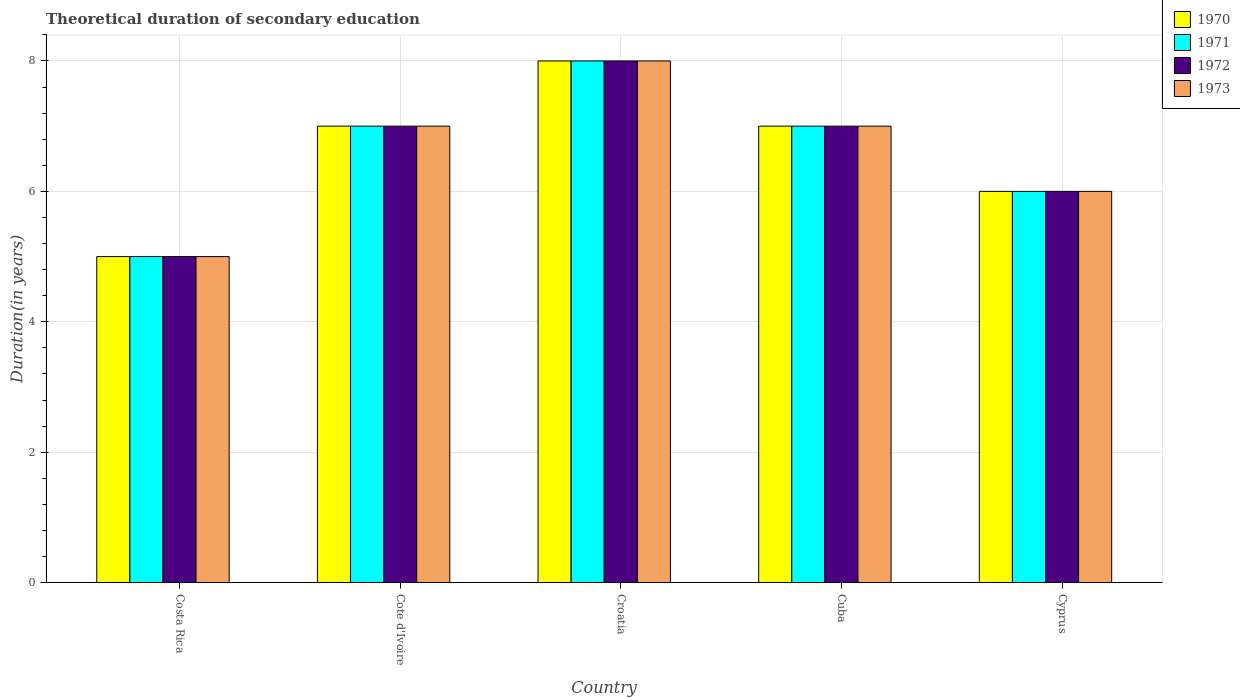How many different coloured bars are there?
Your answer should be very brief. 4. Are the number of bars per tick equal to the number of legend labels?
Keep it short and to the point. Yes. Are the number of bars on each tick of the X-axis equal?
Keep it short and to the point. Yes. How many bars are there on the 4th tick from the left?
Keep it short and to the point. 4. What is the label of the 2nd group of bars from the left?
Keep it short and to the point. Cote d'Ivoire. What is the total theoretical duration of secondary education in 1973 in Cote d'Ivoire?
Ensure brevity in your answer.  7. Across all countries, what is the maximum total theoretical duration of secondary education in 1973?
Ensure brevity in your answer.  8. In which country was the total theoretical duration of secondary education in 1973 maximum?
Your answer should be compact. Croatia. In which country was the total theoretical duration of secondary education in 1970 minimum?
Your response must be concise. Costa Rica. What is the total total theoretical duration of secondary education in 1971 in the graph?
Give a very brief answer. 33. What is the average total theoretical duration of secondary education in 1973 per country?
Offer a very short reply. 6.6. What is the difference between the total theoretical duration of secondary education of/in 1973 and total theoretical duration of secondary education of/in 1970 in Croatia?
Your response must be concise. 0. In how many countries, is the total theoretical duration of secondary education in 1971 greater than 5.6 years?
Give a very brief answer. 4. What is the ratio of the total theoretical duration of secondary education in 1971 in Cuba to that in Cyprus?
Provide a succinct answer. 1.17. Is the total theoretical duration of secondary education in 1971 in Costa Rica less than that in Cuba?
Your response must be concise. Yes. What is the difference between the highest and the lowest total theoretical duration of secondary education in 1972?
Offer a terse response. 3. Is it the case that in every country, the sum of the total theoretical duration of secondary education in 1970 and total theoretical duration of secondary education in 1971 is greater than the sum of total theoretical duration of secondary education in 1973 and total theoretical duration of secondary education in 1972?
Ensure brevity in your answer.  No. What does the 1st bar from the left in Cote d'Ivoire represents?
Give a very brief answer. 1970. Is it the case that in every country, the sum of the total theoretical duration of secondary education in 1973 and total theoretical duration of secondary education in 1972 is greater than the total theoretical duration of secondary education in 1971?
Provide a short and direct response. Yes. How many bars are there?
Provide a succinct answer. 20. What is the difference between two consecutive major ticks on the Y-axis?
Ensure brevity in your answer.  2. Are the values on the major ticks of Y-axis written in scientific E-notation?
Make the answer very short. No. Does the graph contain any zero values?
Offer a terse response. No. What is the title of the graph?
Your response must be concise. Theoretical duration of secondary education. What is the label or title of the X-axis?
Offer a very short reply. Country. What is the label or title of the Y-axis?
Keep it short and to the point. Duration(in years). What is the Duration(in years) in 1971 in Costa Rica?
Your response must be concise. 5. What is the Duration(in years) in 1973 in Costa Rica?
Offer a terse response. 5. What is the Duration(in years) in 1972 in Cote d'Ivoire?
Keep it short and to the point. 7. What is the Duration(in years) in 1973 in Cote d'Ivoire?
Offer a terse response. 7. What is the Duration(in years) of 1970 in Croatia?
Provide a succinct answer. 8. What is the Duration(in years) in 1971 in Croatia?
Keep it short and to the point. 8. What is the Duration(in years) in 1972 in Croatia?
Ensure brevity in your answer.  8. What is the Duration(in years) in 1970 in Cuba?
Your answer should be very brief. 7. Across all countries, what is the minimum Duration(in years) of 1970?
Your answer should be compact. 5. Across all countries, what is the minimum Duration(in years) of 1971?
Provide a succinct answer. 5. Across all countries, what is the minimum Duration(in years) of 1972?
Provide a succinct answer. 5. What is the total Duration(in years) in 1970 in the graph?
Your answer should be compact. 33. What is the total Duration(in years) of 1971 in the graph?
Keep it short and to the point. 33. What is the total Duration(in years) of 1973 in the graph?
Your answer should be very brief. 33. What is the difference between the Duration(in years) of 1970 in Costa Rica and that in Croatia?
Make the answer very short. -3. What is the difference between the Duration(in years) of 1971 in Costa Rica and that in Croatia?
Keep it short and to the point. -3. What is the difference between the Duration(in years) in 1970 in Costa Rica and that in Cuba?
Your answer should be compact. -2. What is the difference between the Duration(in years) of 1971 in Costa Rica and that in Cuba?
Keep it short and to the point. -2. What is the difference between the Duration(in years) in 1972 in Costa Rica and that in Cuba?
Keep it short and to the point. -2. What is the difference between the Duration(in years) of 1973 in Costa Rica and that in Cuba?
Offer a terse response. -2. What is the difference between the Duration(in years) in 1970 in Costa Rica and that in Cyprus?
Give a very brief answer. -1. What is the difference between the Duration(in years) in 1971 in Costa Rica and that in Cyprus?
Provide a short and direct response. -1. What is the difference between the Duration(in years) of 1970 in Cote d'Ivoire and that in Croatia?
Ensure brevity in your answer.  -1. What is the difference between the Duration(in years) of 1971 in Cote d'Ivoire and that in Croatia?
Your answer should be very brief. -1. What is the difference between the Duration(in years) in 1972 in Cote d'Ivoire and that in Croatia?
Provide a succinct answer. -1. What is the difference between the Duration(in years) in 1973 in Cote d'Ivoire and that in Croatia?
Offer a terse response. -1. What is the difference between the Duration(in years) in 1970 in Cote d'Ivoire and that in Cuba?
Your answer should be compact. 0. What is the difference between the Duration(in years) in 1971 in Cote d'Ivoire and that in Cuba?
Make the answer very short. 0. What is the difference between the Duration(in years) in 1972 in Cote d'Ivoire and that in Cyprus?
Your answer should be very brief. 1. What is the difference between the Duration(in years) of 1971 in Croatia and that in Cuba?
Provide a succinct answer. 1. What is the difference between the Duration(in years) in 1971 in Croatia and that in Cyprus?
Make the answer very short. 2. What is the difference between the Duration(in years) in 1972 in Croatia and that in Cyprus?
Offer a very short reply. 2. What is the difference between the Duration(in years) of 1971 in Cuba and that in Cyprus?
Give a very brief answer. 1. What is the difference between the Duration(in years) of 1971 in Costa Rica and the Duration(in years) of 1972 in Cote d'Ivoire?
Ensure brevity in your answer.  -2. What is the difference between the Duration(in years) in 1971 in Costa Rica and the Duration(in years) in 1973 in Cote d'Ivoire?
Make the answer very short. -2. What is the difference between the Duration(in years) of 1972 in Costa Rica and the Duration(in years) of 1973 in Cote d'Ivoire?
Your response must be concise. -2. What is the difference between the Duration(in years) of 1971 in Costa Rica and the Duration(in years) of 1973 in Croatia?
Provide a succinct answer. -3. What is the difference between the Duration(in years) of 1970 in Costa Rica and the Duration(in years) of 1972 in Cuba?
Your answer should be very brief. -2. What is the difference between the Duration(in years) of 1970 in Costa Rica and the Duration(in years) of 1973 in Cuba?
Provide a short and direct response. -2. What is the difference between the Duration(in years) in 1971 in Costa Rica and the Duration(in years) in 1972 in Cuba?
Provide a short and direct response. -2. What is the difference between the Duration(in years) of 1971 in Costa Rica and the Duration(in years) of 1973 in Cuba?
Your answer should be very brief. -2. What is the difference between the Duration(in years) in 1972 in Costa Rica and the Duration(in years) in 1973 in Cuba?
Keep it short and to the point. -2. What is the difference between the Duration(in years) in 1970 in Costa Rica and the Duration(in years) in 1971 in Cyprus?
Provide a short and direct response. -1. What is the difference between the Duration(in years) of 1970 in Costa Rica and the Duration(in years) of 1972 in Cyprus?
Offer a very short reply. -1. What is the difference between the Duration(in years) in 1971 in Costa Rica and the Duration(in years) in 1972 in Cyprus?
Ensure brevity in your answer.  -1. What is the difference between the Duration(in years) in 1971 in Costa Rica and the Duration(in years) in 1973 in Cyprus?
Provide a succinct answer. -1. What is the difference between the Duration(in years) of 1970 in Cote d'Ivoire and the Duration(in years) of 1971 in Croatia?
Keep it short and to the point. -1. What is the difference between the Duration(in years) of 1970 in Cote d'Ivoire and the Duration(in years) of 1972 in Croatia?
Make the answer very short. -1. What is the difference between the Duration(in years) of 1970 in Cote d'Ivoire and the Duration(in years) of 1973 in Cuba?
Your answer should be compact. 0. What is the difference between the Duration(in years) in 1971 in Cote d'Ivoire and the Duration(in years) in 1972 in Cuba?
Your answer should be compact. 0. What is the difference between the Duration(in years) in 1971 in Cote d'Ivoire and the Duration(in years) in 1973 in Cuba?
Ensure brevity in your answer.  0. What is the difference between the Duration(in years) of 1972 in Cote d'Ivoire and the Duration(in years) of 1973 in Cuba?
Provide a short and direct response. 0. What is the difference between the Duration(in years) in 1970 in Cote d'Ivoire and the Duration(in years) in 1971 in Cyprus?
Make the answer very short. 1. What is the difference between the Duration(in years) of 1970 in Cote d'Ivoire and the Duration(in years) of 1973 in Cyprus?
Keep it short and to the point. 1. What is the difference between the Duration(in years) of 1971 in Cote d'Ivoire and the Duration(in years) of 1973 in Cyprus?
Give a very brief answer. 1. What is the difference between the Duration(in years) in 1972 in Cote d'Ivoire and the Duration(in years) in 1973 in Cyprus?
Provide a short and direct response. 1. What is the difference between the Duration(in years) in 1970 in Croatia and the Duration(in years) in 1971 in Cuba?
Offer a very short reply. 1. What is the difference between the Duration(in years) of 1971 in Croatia and the Duration(in years) of 1973 in Cuba?
Ensure brevity in your answer.  1. What is the difference between the Duration(in years) of 1970 in Croatia and the Duration(in years) of 1971 in Cyprus?
Provide a short and direct response. 2. What is the difference between the Duration(in years) of 1970 in Croatia and the Duration(in years) of 1973 in Cyprus?
Your answer should be very brief. 2. What is the difference between the Duration(in years) of 1971 in Croatia and the Duration(in years) of 1972 in Cyprus?
Give a very brief answer. 2. What is the difference between the Duration(in years) of 1970 in Cuba and the Duration(in years) of 1972 in Cyprus?
Your answer should be very brief. 1. What is the difference between the Duration(in years) of 1970 in Cuba and the Duration(in years) of 1973 in Cyprus?
Your answer should be very brief. 1. What is the difference between the Duration(in years) of 1972 in Cuba and the Duration(in years) of 1973 in Cyprus?
Ensure brevity in your answer.  1. What is the average Duration(in years) in 1971 per country?
Give a very brief answer. 6.6. What is the average Duration(in years) in 1972 per country?
Ensure brevity in your answer.  6.6. What is the difference between the Duration(in years) of 1971 and Duration(in years) of 1973 in Costa Rica?
Give a very brief answer. 0. What is the difference between the Duration(in years) of 1971 and Duration(in years) of 1972 in Cote d'Ivoire?
Your answer should be compact. 0. What is the difference between the Duration(in years) of 1970 and Duration(in years) of 1971 in Croatia?
Provide a succinct answer. 0. What is the difference between the Duration(in years) of 1970 and Duration(in years) of 1973 in Croatia?
Offer a very short reply. 0. What is the difference between the Duration(in years) in 1971 and Duration(in years) in 1972 in Croatia?
Provide a short and direct response. 0. What is the difference between the Duration(in years) of 1972 and Duration(in years) of 1973 in Croatia?
Ensure brevity in your answer.  0. What is the difference between the Duration(in years) in 1970 and Duration(in years) in 1971 in Cuba?
Offer a very short reply. 0. What is the difference between the Duration(in years) in 1970 and Duration(in years) in 1972 in Cuba?
Give a very brief answer. 0. What is the difference between the Duration(in years) of 1970 and Duration(in years) of 1973 in Cuba?
Give a very brief answer. 0. What is the difference between the Duration(in years) in 1971 and Duration(in years) in 1972 in Cuba?
Offer a terse response. 0. What is the difference between the Duration(in years) of 1972 and Duration(in years) of 1973 in Cyprus?
Give a very brief answer. 0. What is the ratio of the Duration(in years) in 1971 in Costa Rica to that in Cote d'Ivoire?
Make the answer very short. 0.71. What is the ratio of the Duration(in years) in 1972 in Costa Rica to that in Cote d'Ivoire?
Your response must be concise. 0.71. What is the ratio of the Duration(in years) of 1973 in Costa Rica to that in Cote d'Ivoire?
Offer a terse response. 0.71. What is the ratio of the Duration(in years) in 1970 in Costa Rica to that in Croatia?
Provide a succinct answer. 0.62. What is the ratio of the Duration(in years) of 1971 in Costa Rica to that in Croatia?
Provide a succinct answer. 0.62. What is the ratio of the Duration(in years) of 1972 in Costa Rica to that in Croatia?
Provide a succinct answer. 0.62. What is the ratio of the Duration(in years) in 1973 in Costa Rica to that in Croatia?
Give a very brief answer. 0.62. What is the ratio of the Duration(in years) in 1973 in Costa Rica to that in Cuba?
Your answer should be compact. 0.71. What is the ratio of the Duration(in years) in 1970 in Costa Rica to that in Cyprus?
Provide a short and direct response. 0.83. What is the ratio of the Duration(in years) in 1972 in Cote d'Ivoire to that in Croatia?
Offer a very short reply. 0.88. What is the ratio of the Duration(in years) in 1971 in Cote d'Ivoire to that in Cuba?
Provide a succinct answer. 1. What is the ratio of the Duration(in years) in 1970 in Cote d'Ivoire to that in Cyprus?
Your response must be concise. 1.17. What is the ratio of the Duration(in years) of 1971 in Cote d'Ivoire to that in Cyprus?
Provide a succinct answer. 1.17. What is the ratio of the Duration(in years) of 1972 in Cote d'Ivoire to that in Cyprus?
Your answer should be very brief. 1.17. What is the ratio of the Duration(in years) of 1973 in Cote d'Ivoire to that in Cyprus?
Your response must be concise. 1.17. What is the ratio of the Duration(in years) in 1970 in Croatia to that in Cuba?
Your answer should be very brief. 1.14. What is the ratio of the Duration(in years) in 1970 in Croatia to that in Cyprus?
Provide a succinct answer. 1.33. What is the ratio of the Duration(in years) in 1971 in Croatia to that in Cyprus?
Provide a succinct answer. 1.33. What is the ratio of the Duration(in years) in 1973 in Croatia to that in Cyprus?
Offer a terse response. 1.33. What is the ratio of the Duration(in years) in 1970 in Cuba to that in Cyprus?
Offer a terse response. 1.17. What is the ratio of the Duration(in years) in 1972 in Cuba to that in Cyprus?
Keep it short and to the point. 1.17. What is the ratio of the Duration(in years) in 1973 in Cuba to that in Cyprus?
Your answer should be compact. 1.17. What is the difference between the highest and the second highest Duration(in years) of 1970?
Your response must be concise. 1. What is the difference between the highest and the second highest Duration(in years) in 1971?
Keep it short and to the point. 1. What is the difference between the highest and the lowest Duration(in years) of 1973?
Ensure brevity in your answer.  3. 